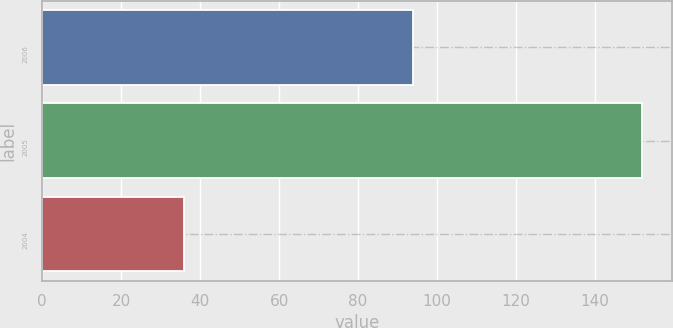Convert chart. <chart><loc_0><loc_0><loc_500><loc_500><bar_chart><fcel>2006<fcel>2005<fcel>2004<nl><fcel>94<fcel>152<fcel>36<nl></chart> 